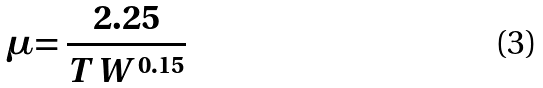<formula> <loc_0><loc_0><loc_500><loc_500>\mu = \frac { 2 . 2 5 } { T W ^ { 0 . 1 5 } }</formula> 